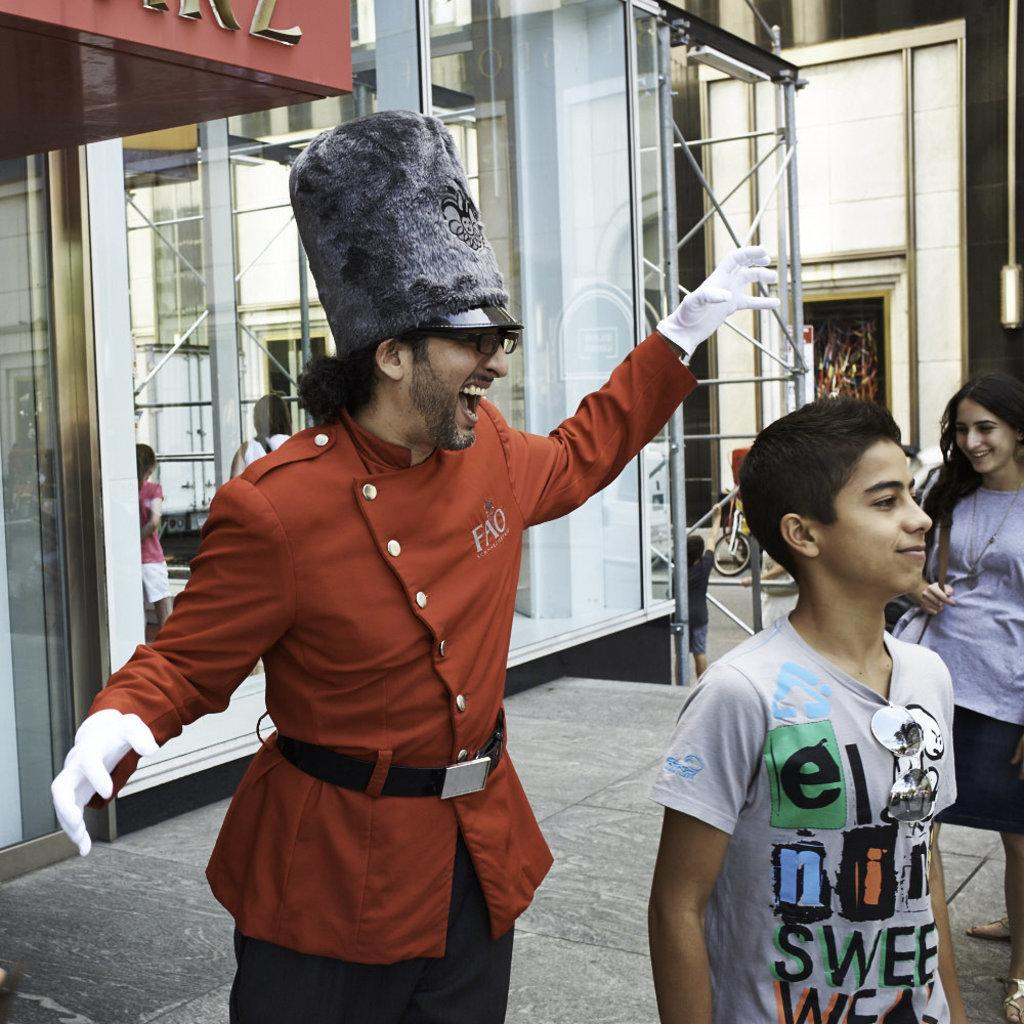What is the main subject of the image? There is a person standing in the image. Can you describe the person's attire? The person is wearing a cap. What else can be seen in the image besides the person? There are other people standing on a footpath in the image. What is visible in the background of the image? There are buildings visible in the background of the image. What type of bubble can be seen in the image? There is no bubble present in the image. 